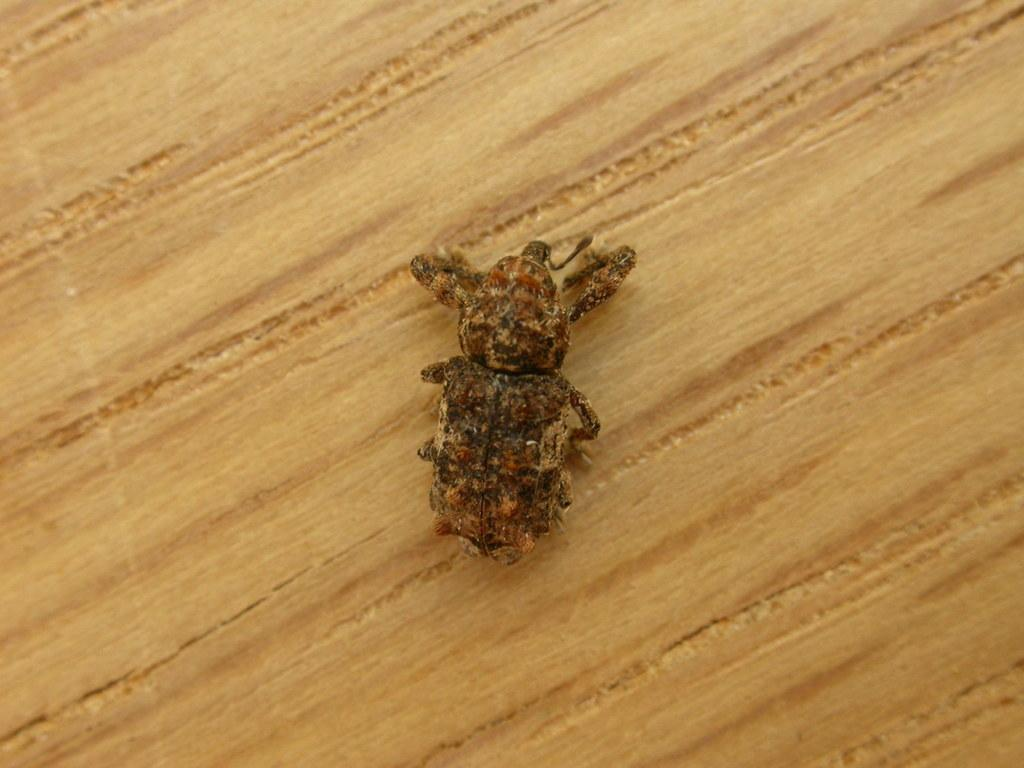What type of creature can be seen in the image? There is an insect in the image. Where is the insect located? The insect is on a wooden surface. What month is depicted in the image? There is no month depicted in the image, as it only features an insect on a wooden surface. What type of spoon can be seen in the image? There is no spoon present in the image. 